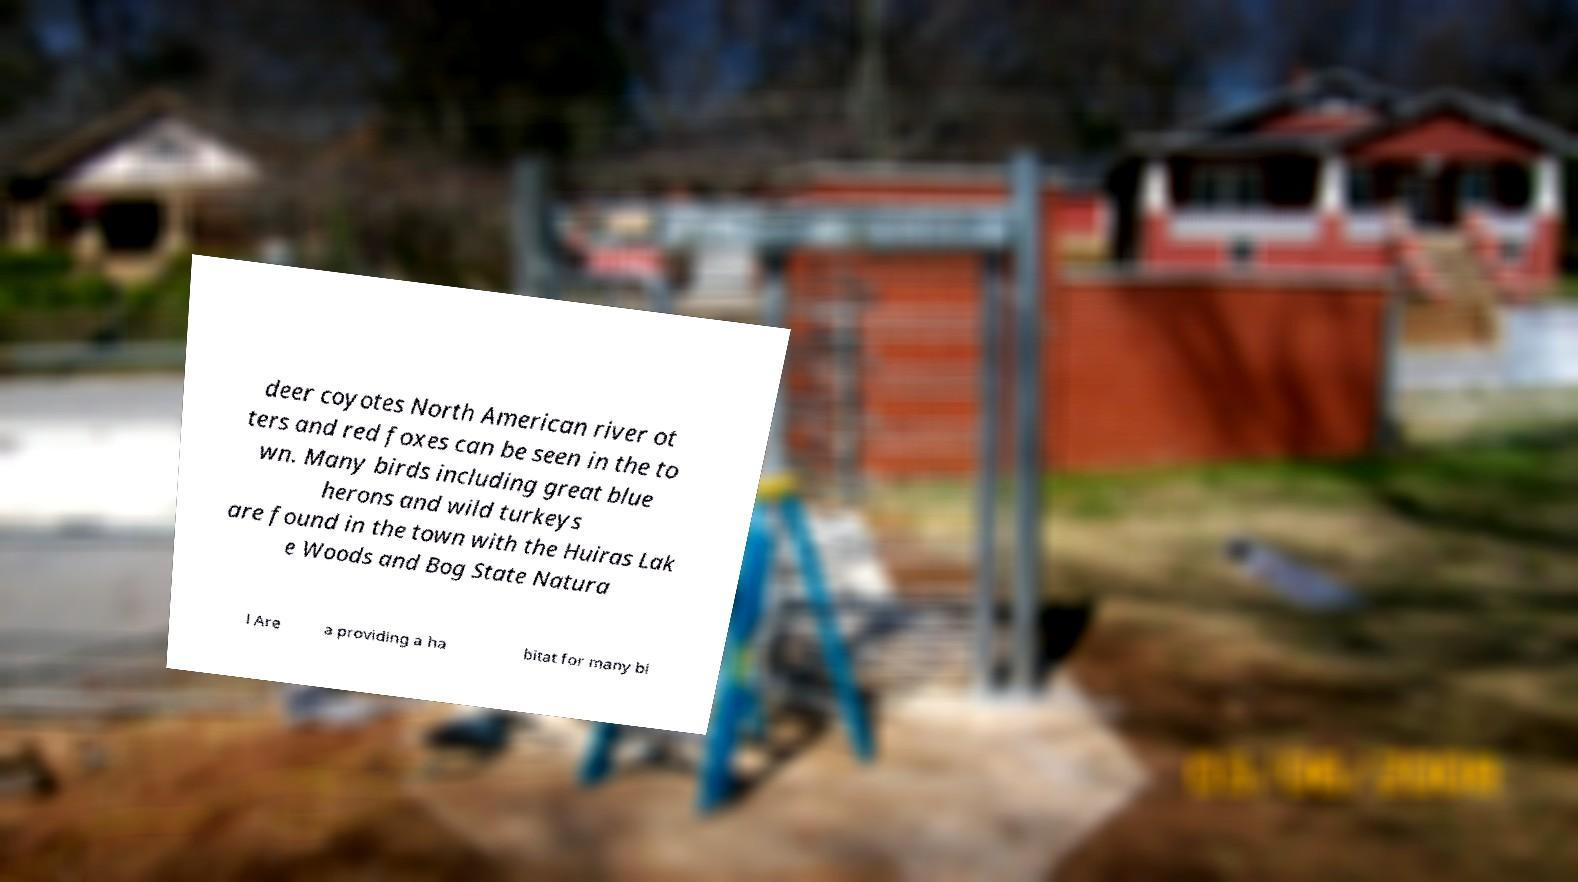What messages or text are displayed in this image? I need them in a readable, typed format. deer coyotes North American river ot ters and red foxes can be seen in the to wn. Many birds including great blue herons and wild turkeys are found in the town with the Huiras Lak e Woods and Bog State Natura l Are a providing a ha bitat for many bi 